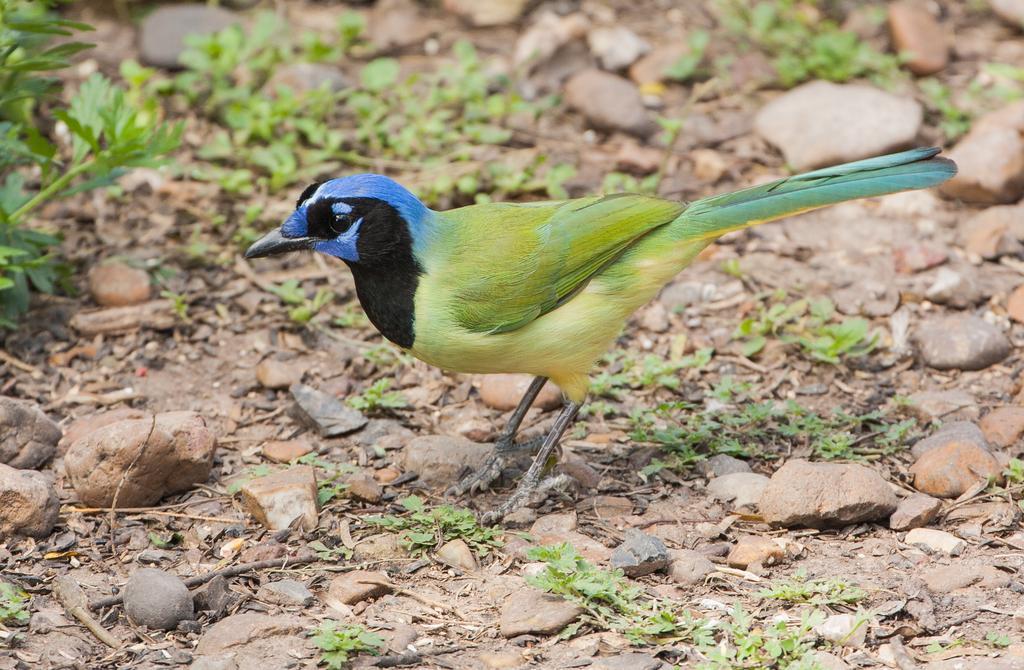Please provide a concise description of this image. In this image, we can see a colorful bird is standing on the ground. Here we can see stones and plants. 